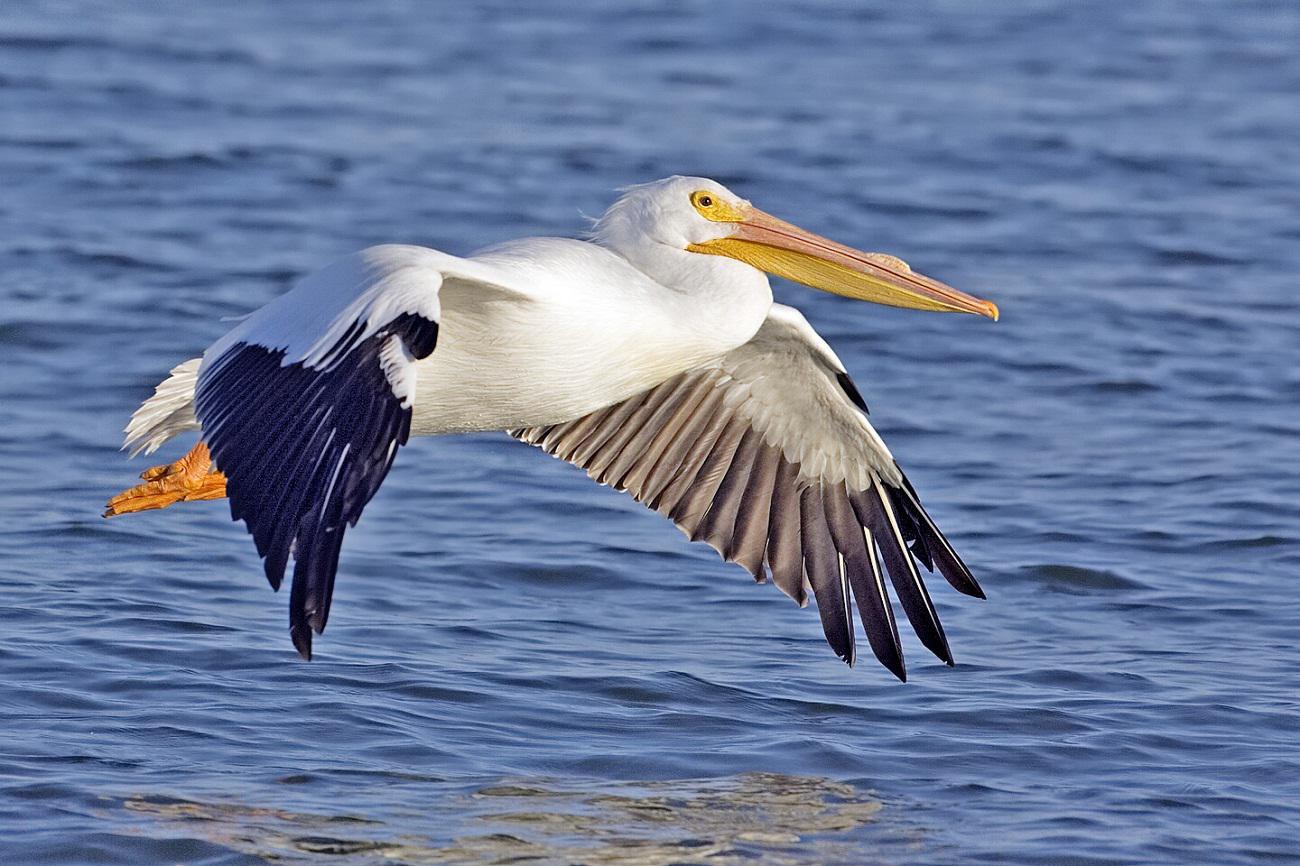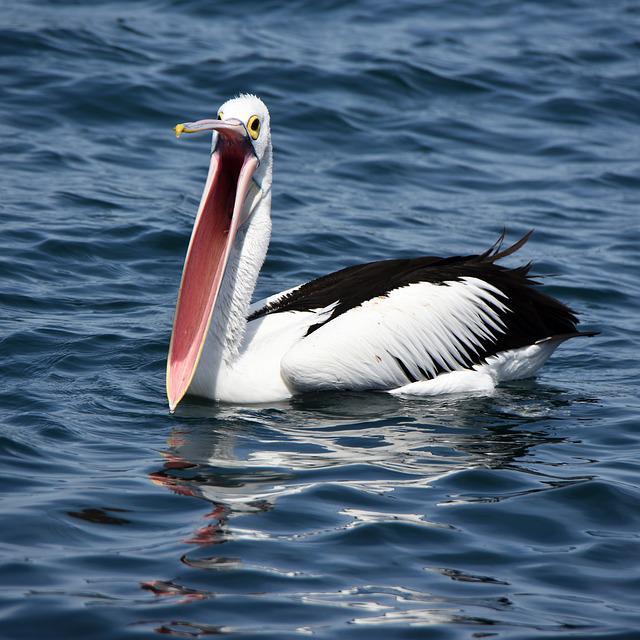The first image is the image on the left, the second image is the image on the right. For the images displayed, is the sentence "Both of the birds are in the air above the water." factually correct? Answer yes or no. No. 